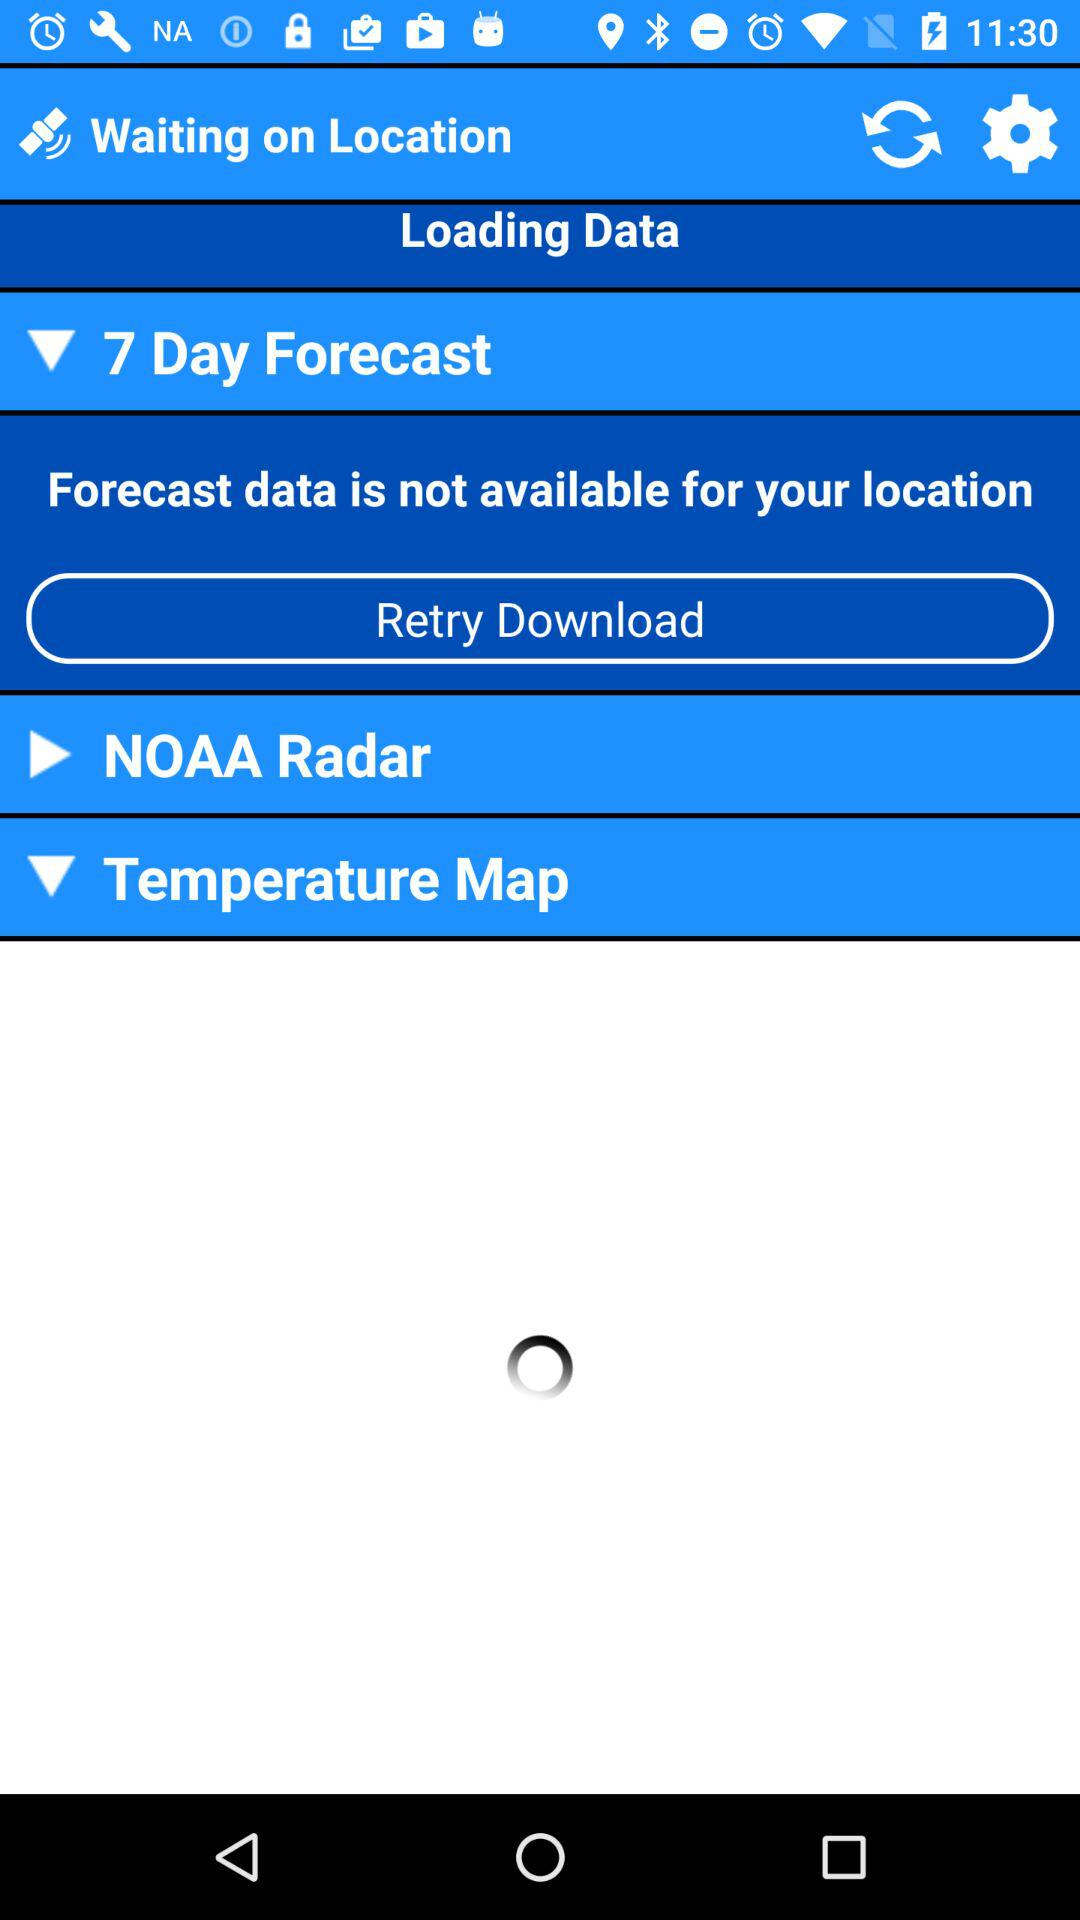For how many days is the forecast? The forecast is for 7 days. 